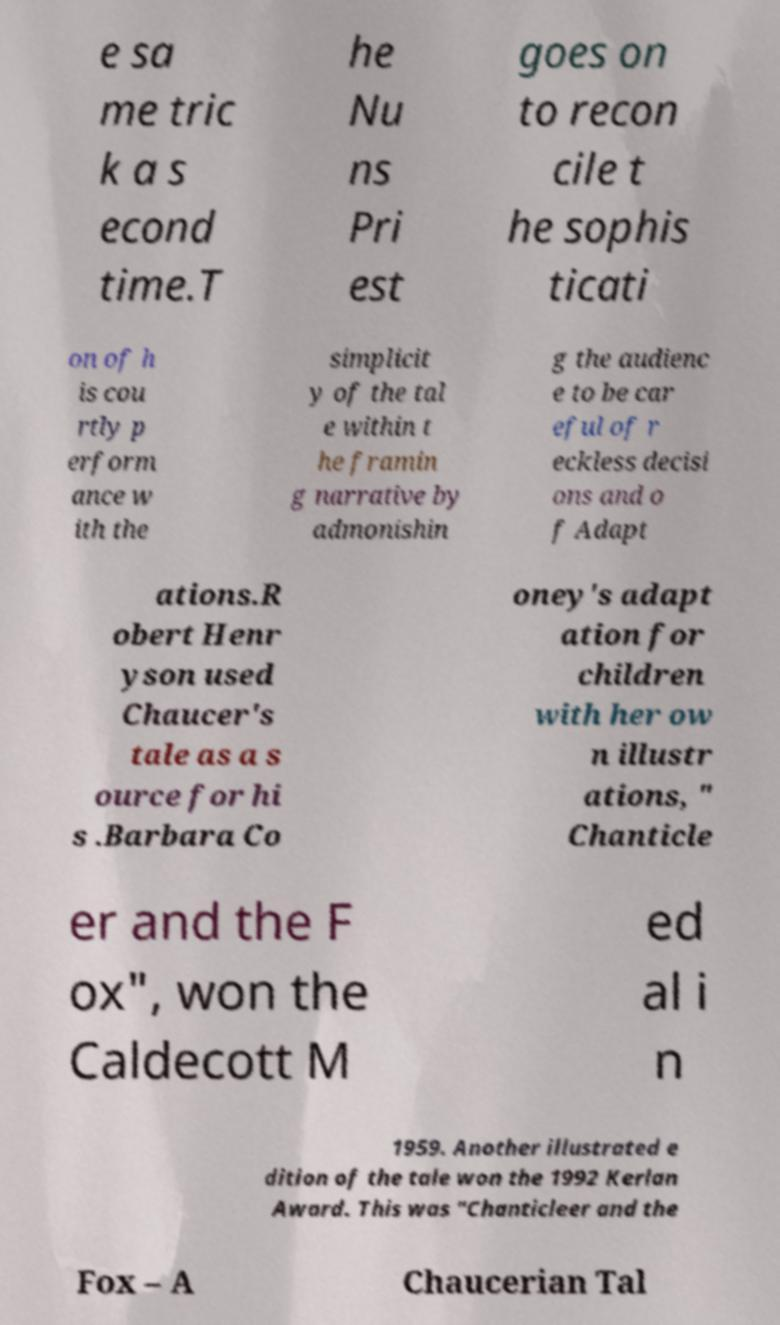Could you extract and type out the text from this image? e sa me tric k a s econd time.T he Nu ns Pri est goes on to recon cile t he sophis ticati on of h is cou rtly p erform ance w ith the simplicit y of the tal e within t he framin g narrative by admonishin g the audienc e to be car eful of r eckless decisi ons and o f Adapt ations.R obert Henr yson used Chaucer's tale as a s ource for hi s .Barbara Co oney's adapt ation for children with her ow n illustr ations, " Chanticle er and the F ox", won the Caldecott M ed al i n 1959. Another illustrated e dition of the tale won the 1992 Kerlan Award. This was "Chanticleer and the Fox – A Chaucerian Tal 